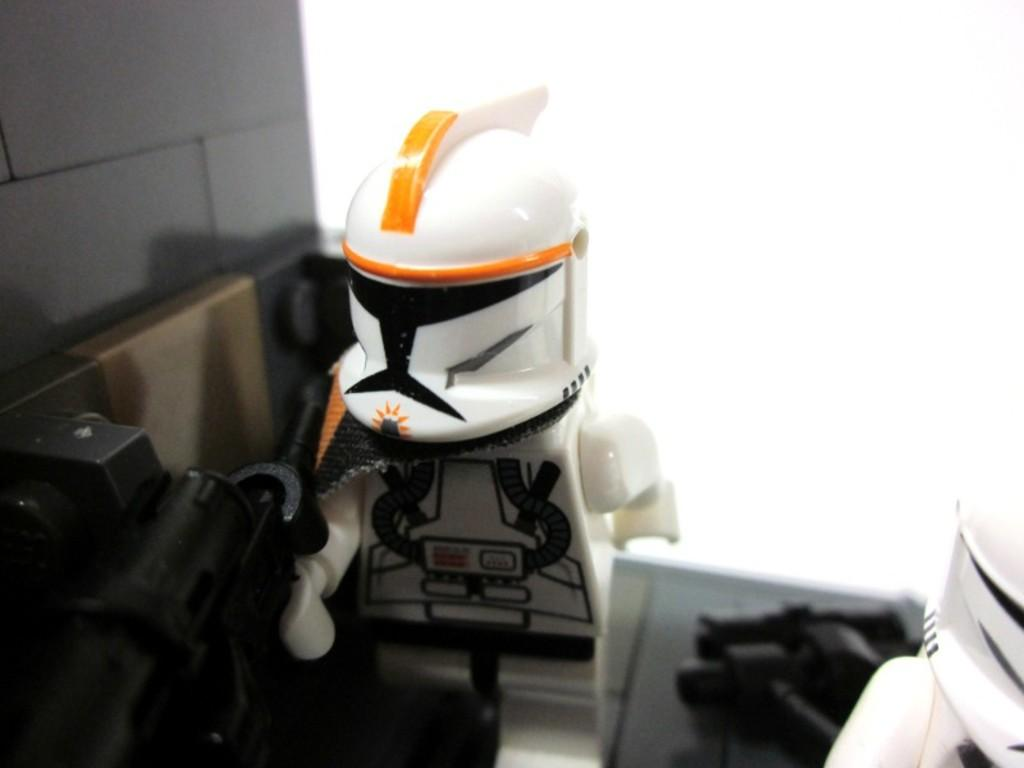What objects can be seen in the image? There are toys in the image. What is located on the left side of the image? There is a wall on the left side of the image. What invention is being demonstrated by the toys in the image? There is no invention being demonstrated by the toys in the image; they are simply toys. Can you see a key in the image? There is no key present in the image. 